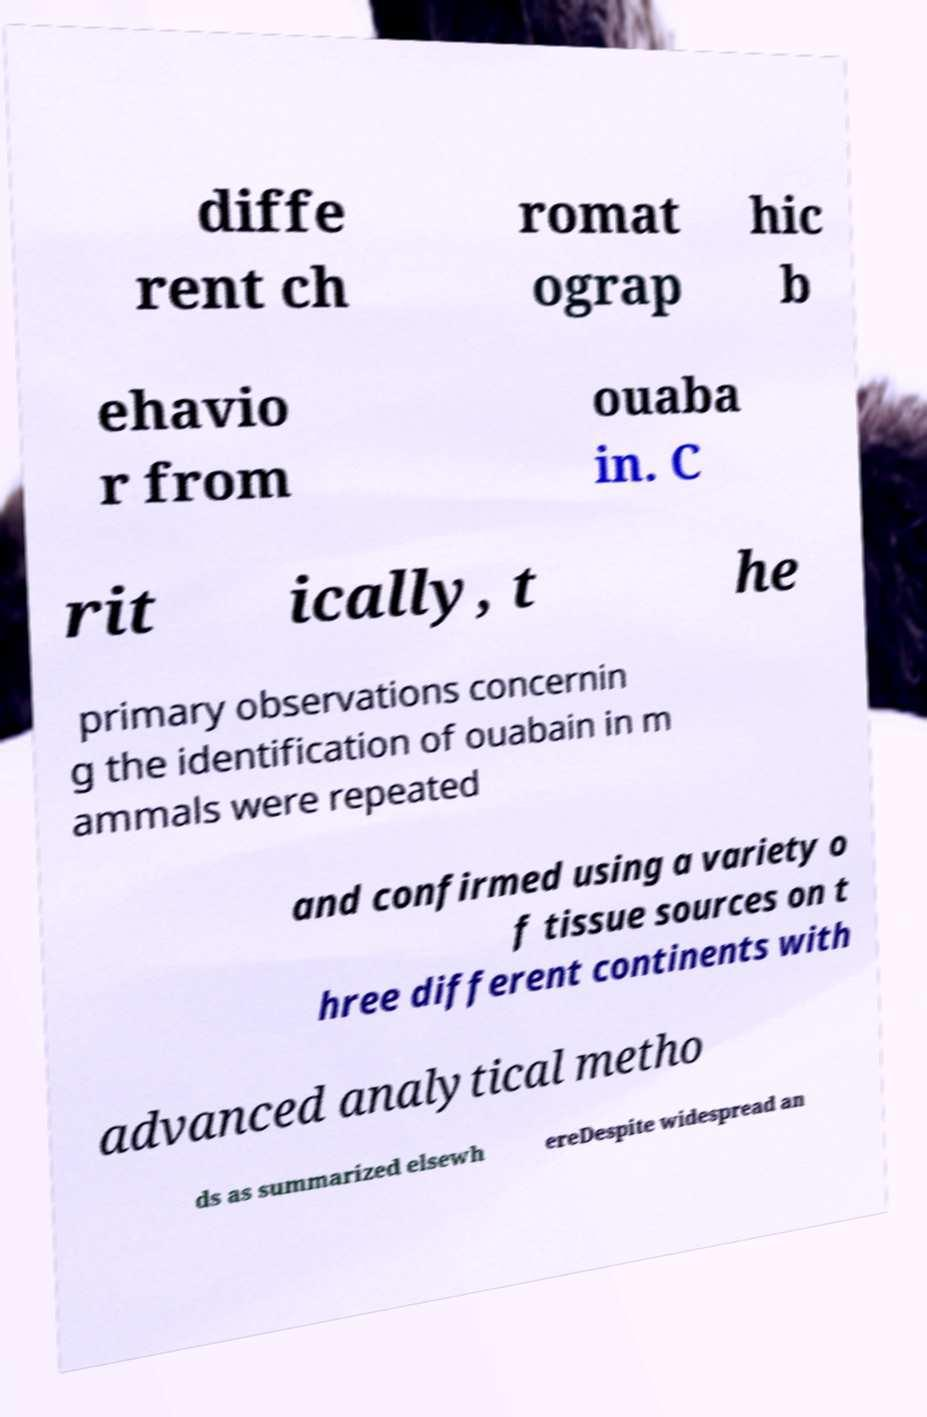Could you extract and type out the text from this image? diffe rent ch romat ograp hic b ehavio r from ouaba in. C rit ically, t he primary observations concernin g the identification of ouabain in m ammals were repeated and confirmed using a variety o f tissue sources on t hree different continents with advanced analytical metho ds as summarized elsewh ereDespite widespread an 